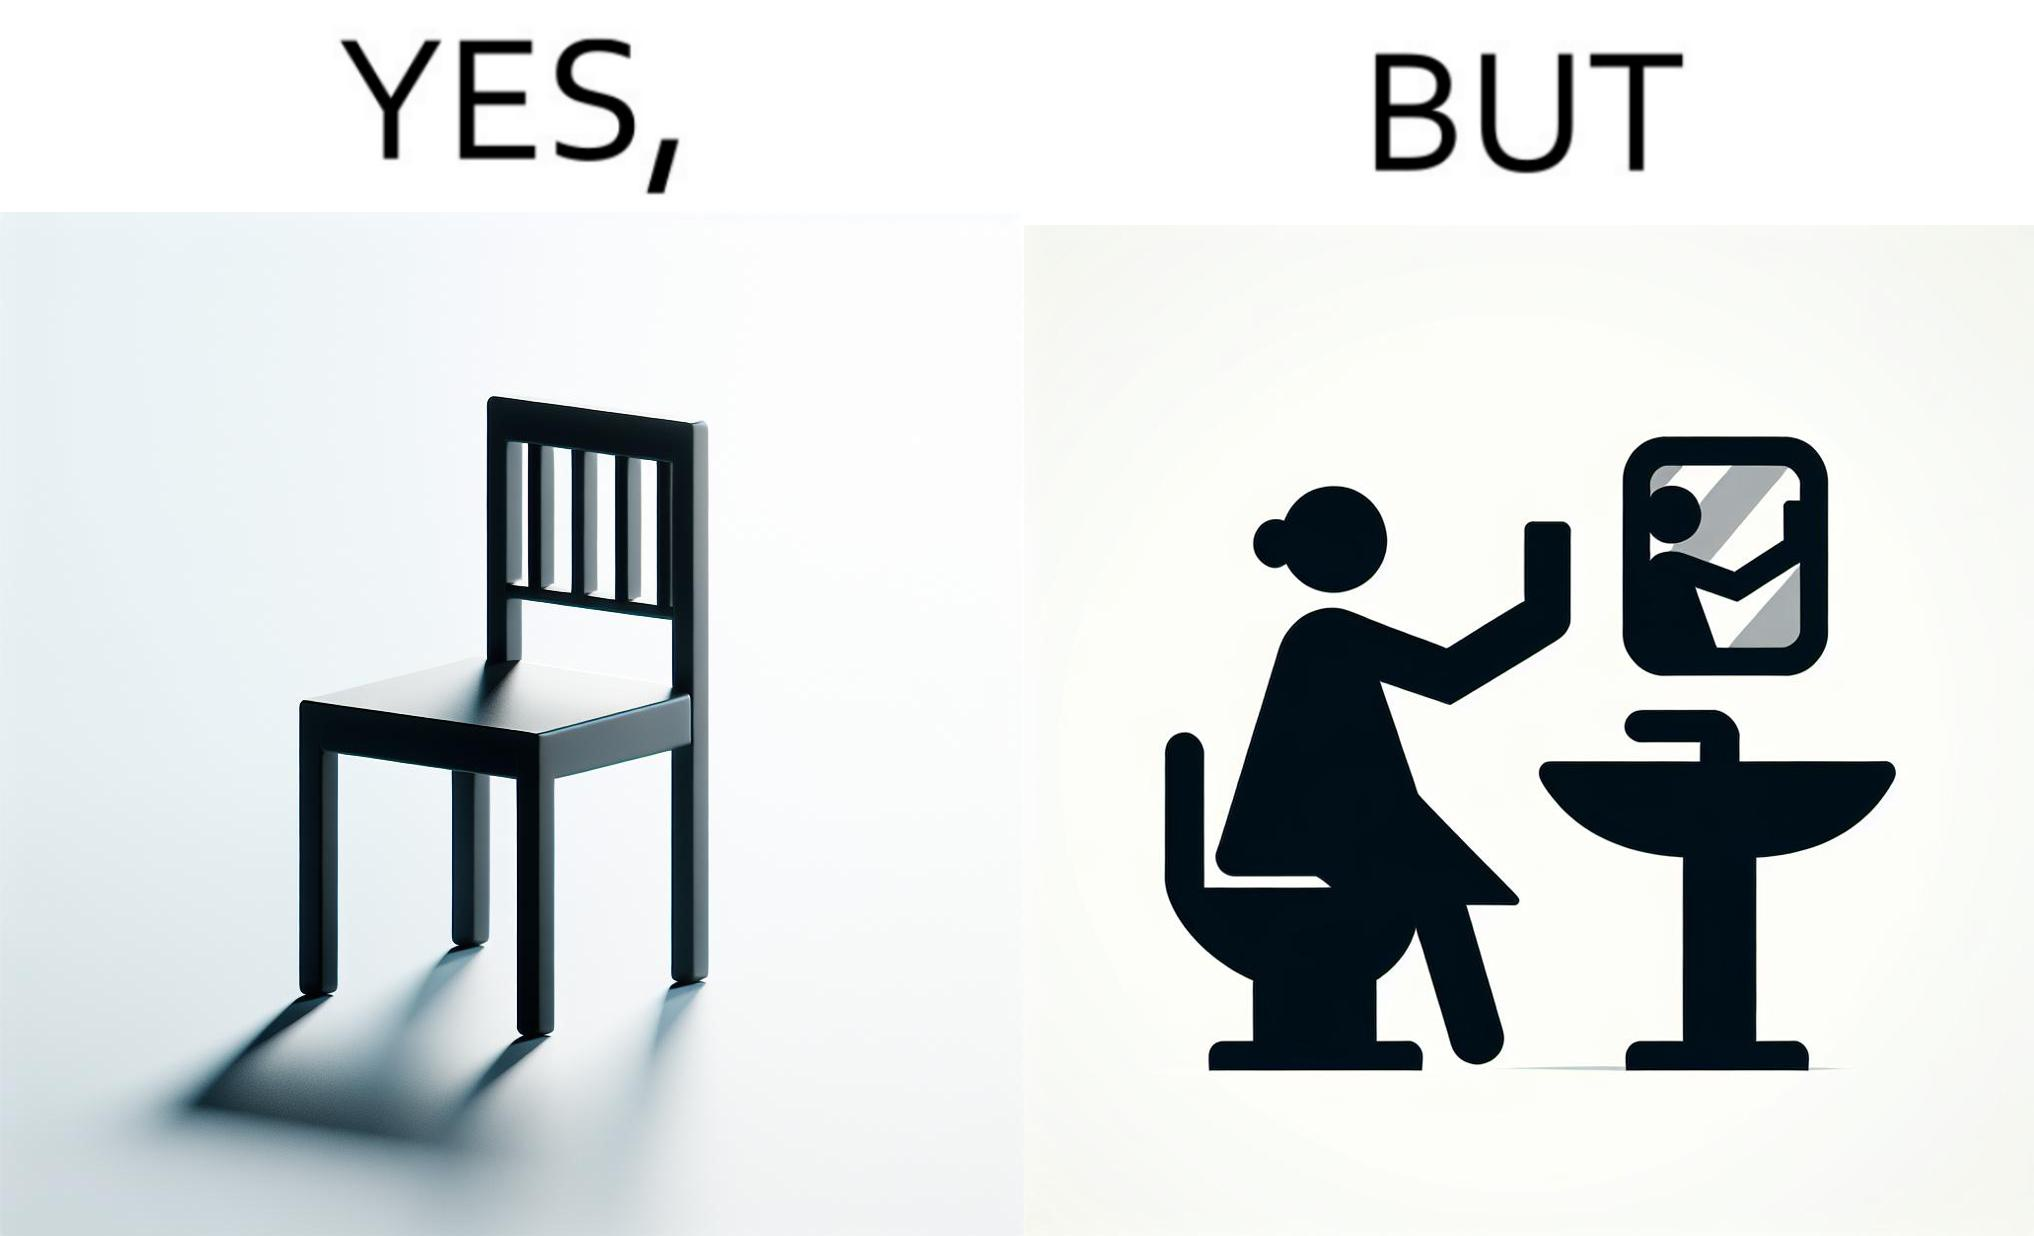What is shown in the left half versus the right half of this image? In the left part of the image: a chair. In the right part of the image: a woman sitting by the sink taking a selfie using a mirror. 